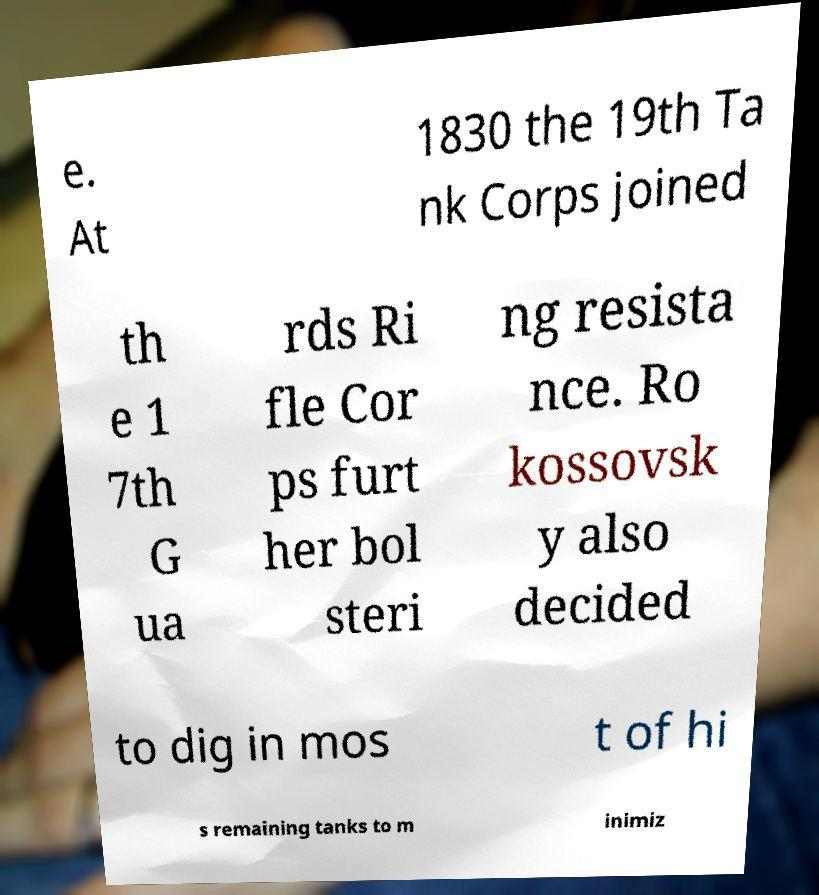There's text embedded in this image that I need extracted. Can you transcribe it verbatim? e. At 1830 the 19th Ta nk Corps joined th e 1 7th G ua rds Ri fle Cor ps furt her bol steri ng resista nce. Ro kossovsk y also decided to dig in mos t of hi s remaining tanks to m inimiz 